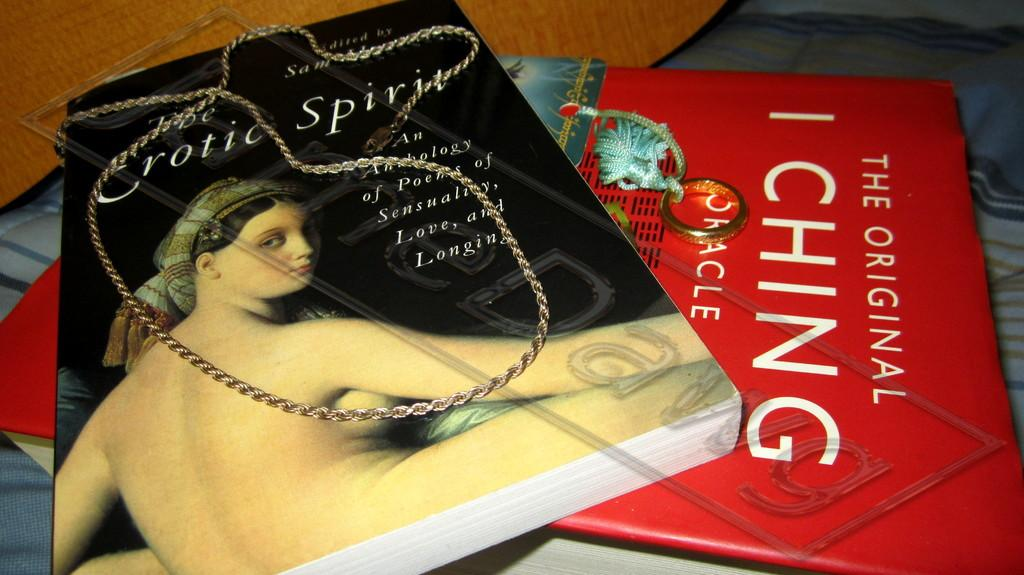<image>
Offer a succinct explanation of the picture presented. Two book lying on top of one another with one title Erotic Spirit and the other I Ching. 